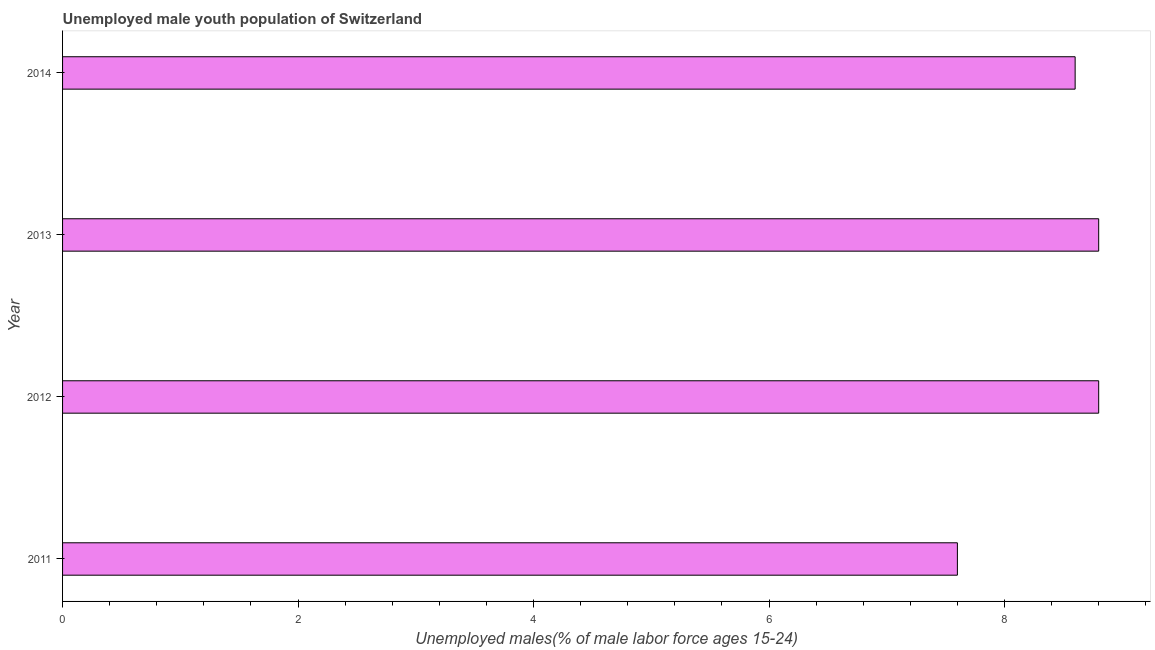Does the graph contain any zero values?
Offer a very short reply. No. Does the graph contain grids?
Offer a terse response. No. What is the title of the graph?
Offer a terse response. Unemployed male youth population of Switzerland. What is the label or title of the X-axis?
Offer a very short reply. Unemployed males(% of male labor force ages 15-24). What is the unemployed male youth in 2014?
Provide a succinct answer. 8.6. Across all years, what is the maximum unemployed male youth?
Keep it short and to the point. 8.8. Across all years, what is the minimum unemployed male youth?
Provide a succinct answer. 7.6. In which year was the unemployed male youth maximum?
Ensure brevity in your answer.  2012. What is the sum of the unemployed male youth?
Your answer should be very brief. 33.8. What is the difference between the unemployed male youth in 2012 and 2013?
Your response must be concise. 0. What is the average unemployed male youth per year?
Your answer should be very brief. 8.45. What is the median unemployed male youth?
Make the answer very short. 8.7. In how many years, is the unemployed male youth greater than 4.8 %?
Provide a succinct answer. 4. Do a majority of the years between 2014 and 2013 (inclusive) have unemployed male youth greater than 0.4 %?
Provide a short and direct response. No. What is the ratio of the unemployed male youth in 2011 to that in 2012?
Offer a very short reply. 0.86. Is the unemployed male youth in 2011 less than that in 2013?
Your answer should be very brief. Yes. What is the difference between the highest and the second highest unemployed male youth?
Provide a succinct answer. 0. What is the difference between the highest and the lowest unemployed male youth?
Offer a terse response. 1.2. In how many years, is the unemployed male youth greater than the average unemployed male youth taken over all years?
Keep it short and to the point. 3. How many bars are there?
Provide a succinct answer. 4. What is the difference between two consecutive major ticks on the X-axis?
Your response must be concise. 2. What is the Unemployed males(% of male labor force ages 15-24) of 2011?
Your answer should be compact. 7.6. What is the Unemployed males(% of male labor force ages 15-24) in 2012?
Offer a very short reply. 8.8. What is the Unemployed males(% of male labor force ages 15-24) in 2013?
Your answer should be compact. 8.8. What is the Unemployed males(% of male labor force ages 15-24) in 2014?
Give a very brief answer. 8.6. What is the difference between the Unemployed males(% of male labor force ages 15-24) in 2012 and 2013?
Give a very brief answer. 0. What is the difference between the Unemployed males(% of male labor force ages 15-24) in 2012 and 2014?
Provide a succinct answer. 0.2. What is the ratio of the Unemployed males(% of male labor force ages 15-24) in 2011 to that in 2012?
Provide a short and direct response. 0.86. What is the ratio of the Unemployed males(% of male labor force ages 15-24) in 2011 to that in 2013?
Make the answer very short. 0.86. What is the ratio of the Unemployed males(% of male labor force ages 15-24) in 2011 to that in 2014?
Offer a terse response. 0.88. What is the ratio of the Unemployed males(% of male labor force ages 15-24) in 2012 to that in 2013?
Provide a short and direct response. 1. 